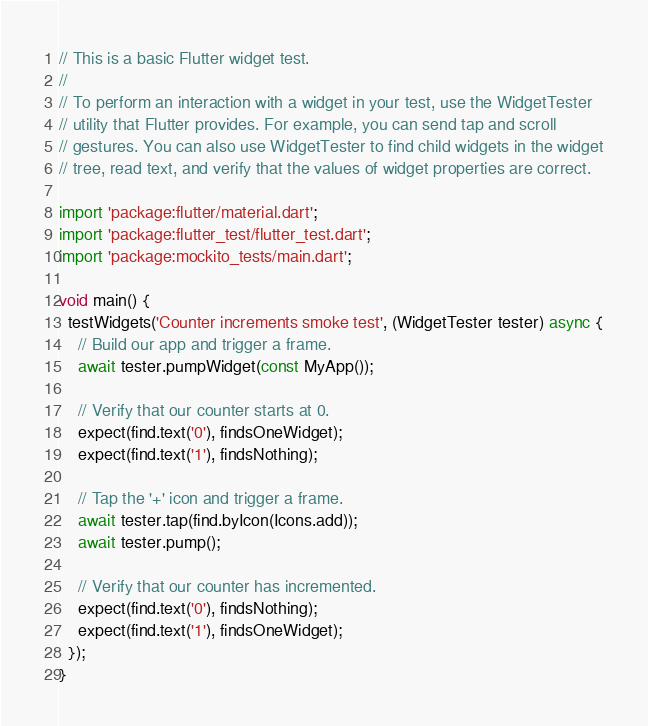Convert code to text. <code><loc_0><loc_0><loc_500><loc_500><_Dart_>// This is a basic Flutter widget test.
//
// To perform an interaction with a widget in your test, use the WidgetTester
// utility that Flutter provides. For example, you can send tap and scroll
// gestures. You can also use WidgetTester to find child widgets in the widget
// tree, read text, and verify that the values of widget properties are correct.

import 'package:flutter/material.dart';
import 'package:flutter_test/flutter_test.dart';
import 'package:mockito_tests/main.dart';

void main() {
  testWidgets('Counter increments smoke test', (WidgetTester tester) async {
    // Build our app and trigger a frame.
    await tester.pumpWidget(const MyApp());

    // Verify that our counter starts at 0.
    expect(find.text('0'), findsOneWidget);
    expect(find.text('1'), findsNothing);

    // Tap the '+' icon and trigger a frame.
    await tester.tap(find.byIcon(Icons.add));
    await tester.pump();

    // Verify that our counter has incremented.
    expect(find.text('0'), findsNothing);
    expect(find.text('1'), findsOneWidget);
  });
}
</code> 